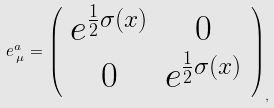Convert formula to latex. <formula><loc_0><loc_0><loc_500><loc_500>e ^ { a } _ { \, \mu } = \left ( \begin{array} { c c } e ^ { \frac { 1 } { 2 } \sigma ( x ) } & 0 \\ 0 & e ^ { \frac { 1 } { 2 } \sigma ( x ) } \end{array} \right ) _ { , }</formula> 